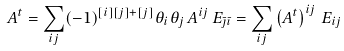<formula> <loc_0><loc_0><loc_500><loc_500>A ^ { t } = \sum _ { i j } ( - 1 ) ^ { [ i ] [ j ] + [ j ] } \theta _ { i } \theta _ { j } \, A ^ { i j } \, E _ { \bar { \jmath } \bar { \imath } } = \sum _ { i j } \left ( A ^ { t } \right ) ^ { i j } \, E _ { i j }</formula> 